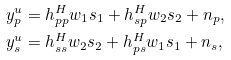Convert formula to latex. <formula><loc_0><loc_0><loc_500><loc_500>y _ { p } ^ { u } & = h _ { p p } ^ { H } w _ { 1 } { s } _ { 1 } + h _ { s p } ^ { H } w _ { 2 } { s } _ { 2 } + n _ { p } , \\ y _ { s } ^ { u } & = h _ { s s } ^ { H } w _ { 2 } { s } _ { 2 } + h _ { p s } ^ { H } w _ { 1 } { s } _ { 1 } + n _ { s } ,</formula> 